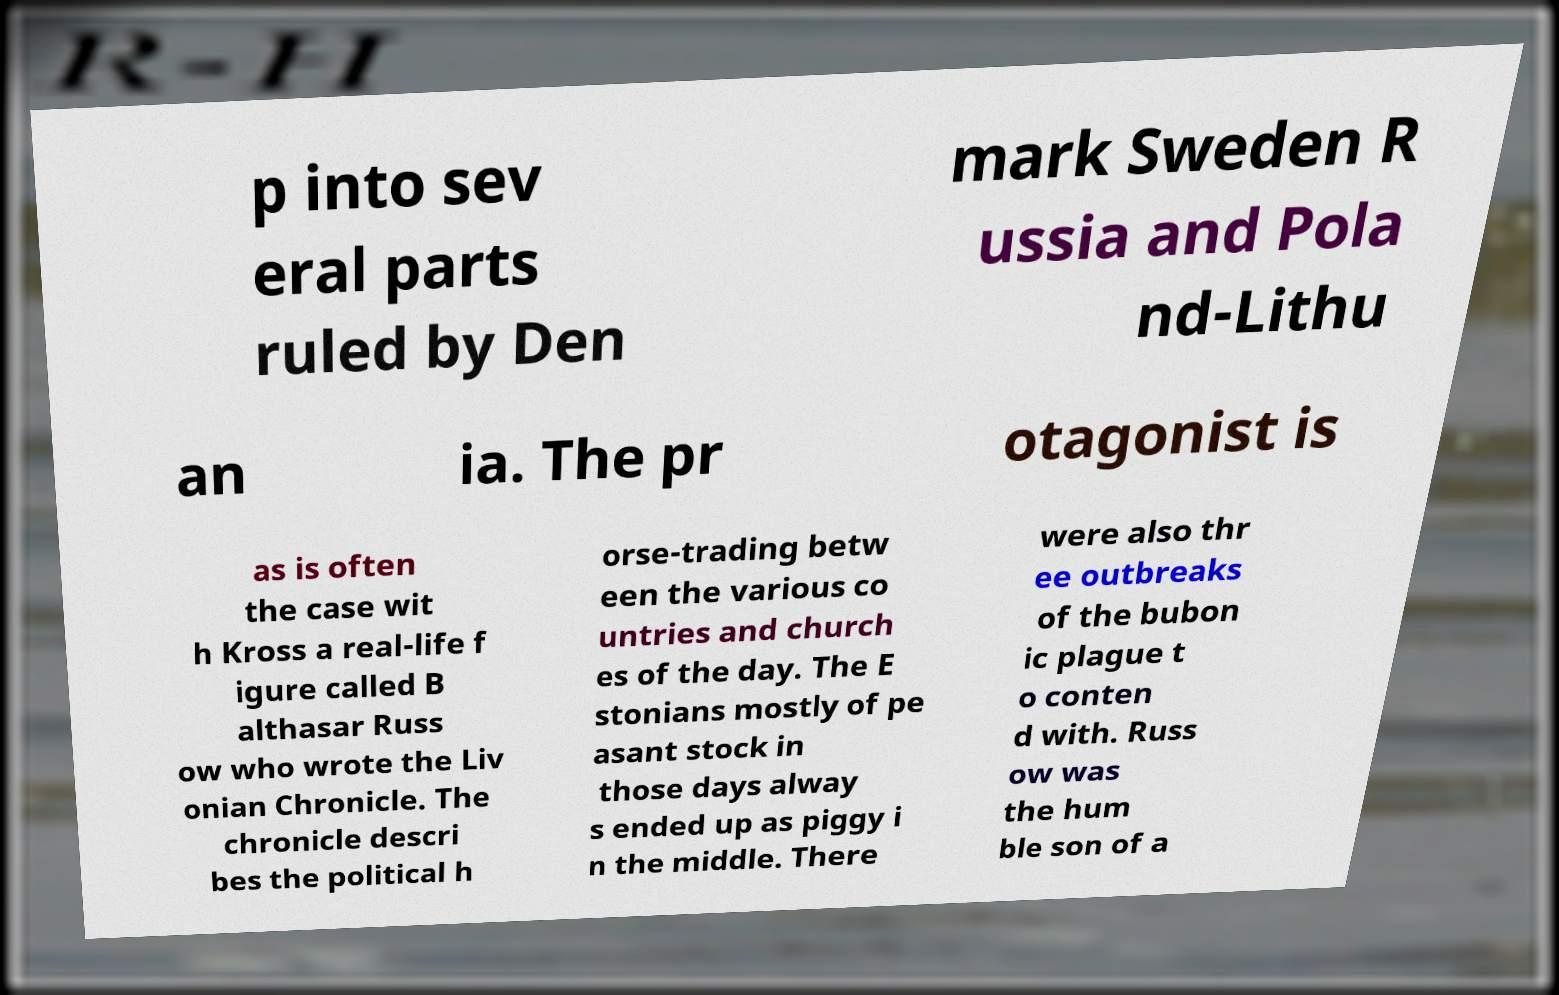I need the written content from this picture converted into text. Can you do that? p into sev eral parts ruled by Den mark Sweden R ussia and Pola nd-Lithu an ia. The pr otagonist is as is often the case wit h Kross a real-life f igure called B althasar Russ ow who wrote the Liv onian Chronicle. The chronicle descri bes the political h orse-trading betw een the various co untries and church es of the day. The E stonians mostly of pe asant stock in those days alway s ended up as piggy i n the middle. There were also thr ee outbreaks of the bubon ic plague t o conten d with. Russ ow was the hum ble son of a 